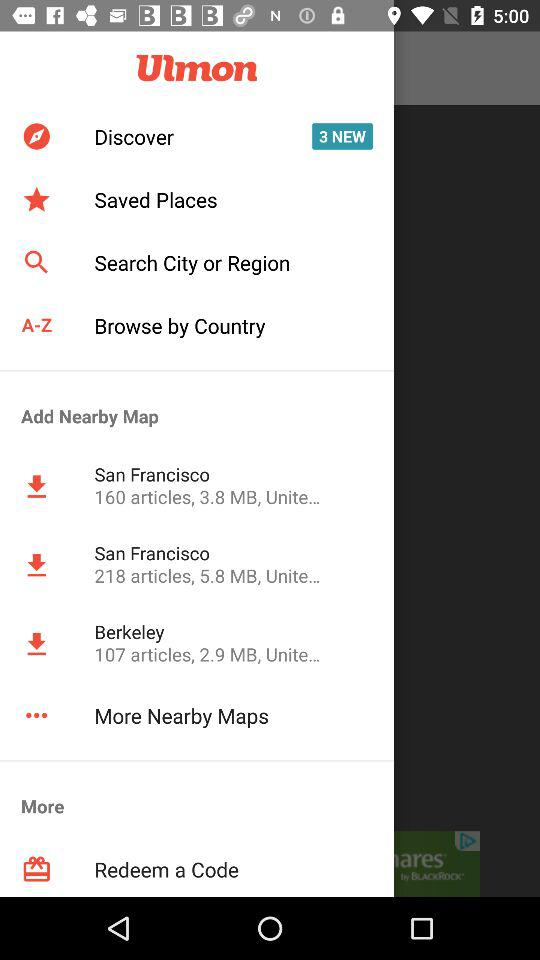What is the total number of notifications in "Discover"? The total number of notifications is 3. 